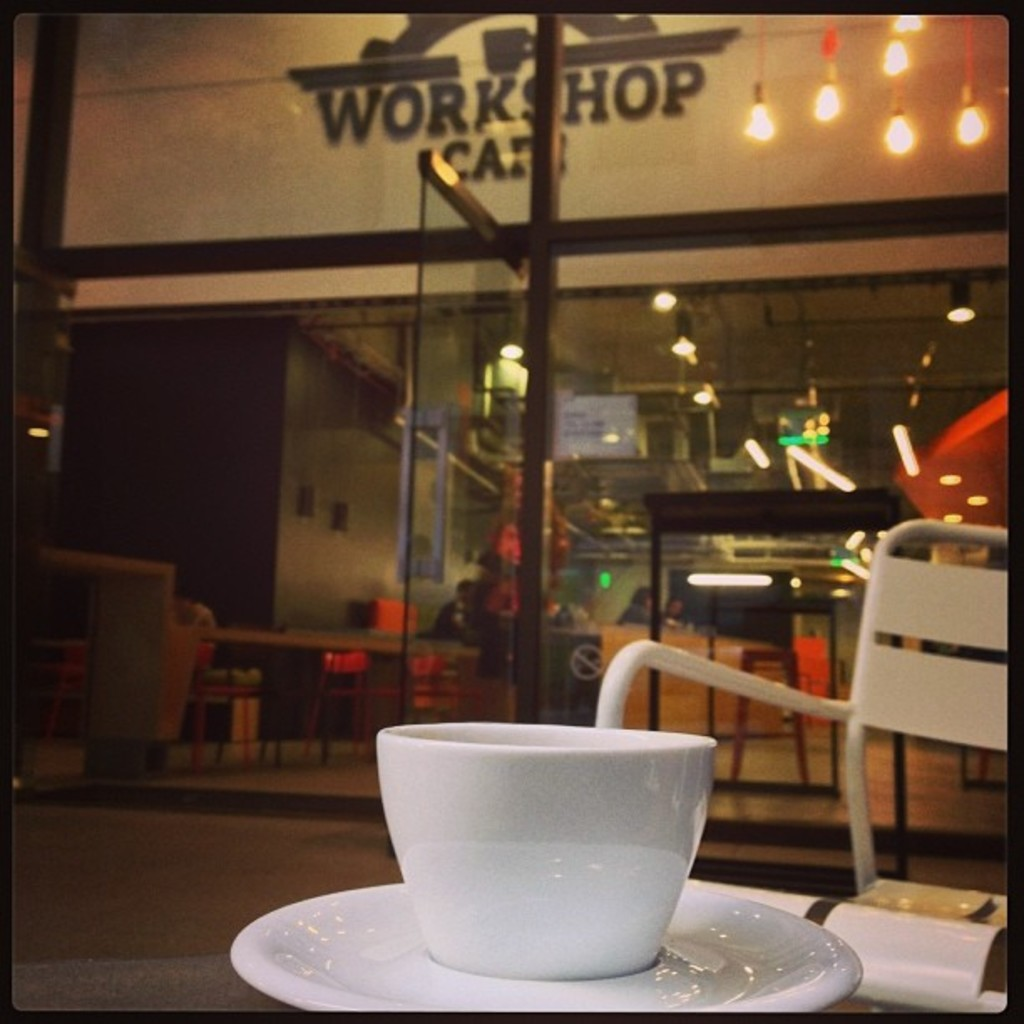What does the cup in the foreground suggest about the moment being depicted? The cup in the foreground, pristine and undisturbed, suggests a moment of pause or reflection, possibly a quiet break amidst the lively ambiance of the cafe. 